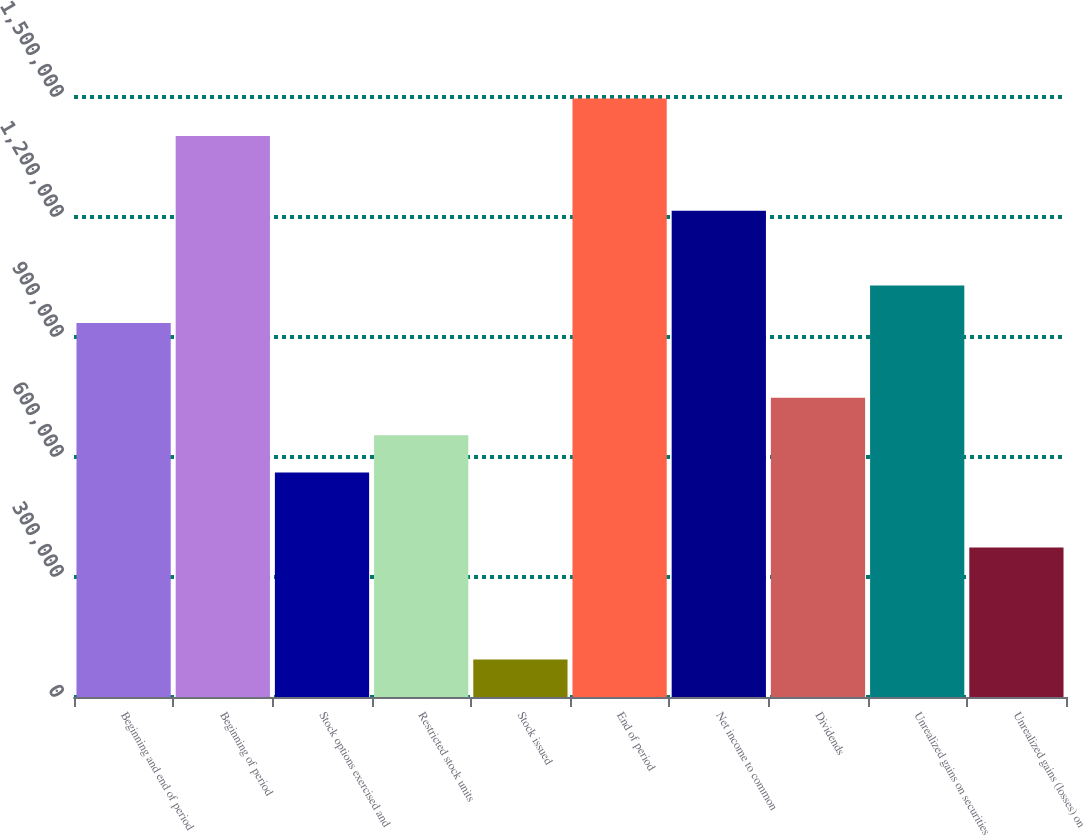<chart> <loc_0><loc_0><loc_500><loc_500><bar_chart><fcel>Beginning and end of period<fcel>Beginning of period<fcel>Stock options exercised and<fcel>Restricted stock units<fcel>Stock issued<fcel>End of period<fcel>Net income to common<fcel>Dividends<fcel>Unrealized gains on securities<fcel>Unrealized gains (losses) on<nl><fcel>935099<fcel>1.40264e+06<fcel>561063<fcel>654572<fcel>93517.1<fcel>1.49615e+06<fcel>1.21563e+06<fcel>748081<fcel>1.02861e+06<fcel>374044<nl></chart> 